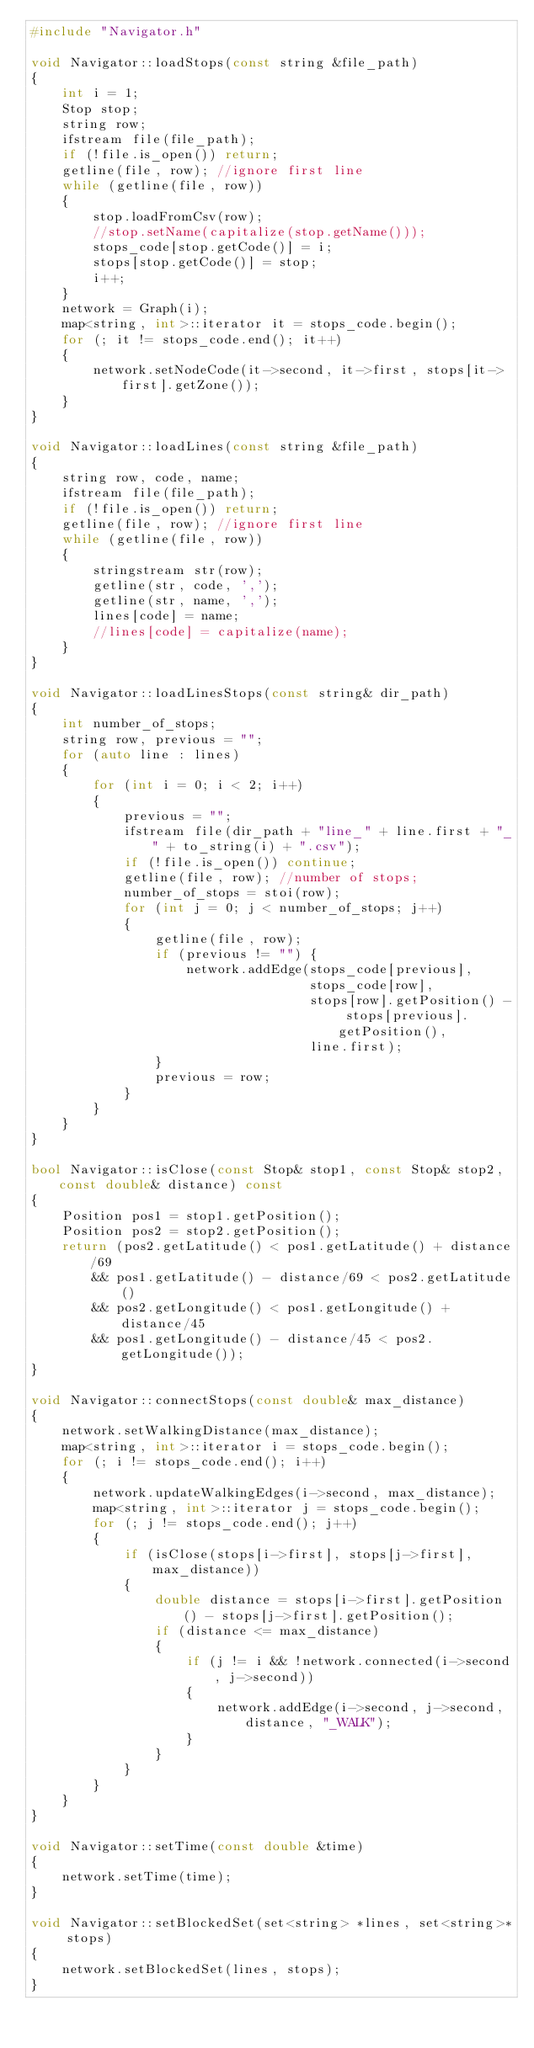<code> <loc_0><loc_0><loc_500><loc_500><_C++_>#include "Navigator.h"

void Navigator::loadStops(const string &file_path)
{
    int i = 1;
    Stop stop;
    string row;
    ifstream file(file_path);
    if (!file.is_open()) return;
    getline(file, row); //ignore first line
    while (getline(file, row))
    {
        stop.loadFromCsv(row);
        //stop.setName(capitalize(stop.getName()));
        stops_code[stop.getCode()] = i;
        stops[stop.getCode()] = stop;
        i++;
    }
    network = Graph(i);
    map<string, int>::iterator it = stops_code.begin();
    for (; it != stops_code.end(); it++)
    {
        network.setNodeCode(it->second, it->first, stops[it->first].getZone());
    }
}

void Navigator::loadLines(const string &file_path)
{
    string row, code, name;
    ifstream file(file_path);
    if (!file.is_open()) return;
    getline(file, row); //ignore first line
    while (getline(file, row))
    {
        stringstream str(row);
        getline(str, code, ',');
        getline(str, name, ',');
        lines[code] = name;
        //lines[code] = capitalize(name);
    }
}

void Navigator::loadLinesStops(const string& dir_path)
{
    int number_of_stops;
    string row, previous = "";
    for (auto line : lines)
    {
        for (int i = 0; i < 2; i++)
        {
            previous = "";
            ifstream file(dir_path + "line_" + line.first + "_" + to_string(i) + ".csv");
            if (!file.is_open()) continue;
            getline(file, row); //number of stops;
            number_of_stops = stoi(row);
            for (int j = 0; j < number_of_stops; j++)
            {
                getline(file, row);
                if (previous != "") {
                    network.addEdge(stops_code[previous],
                                    stops_code[row],
                                    stops[row].getPosition() - stops[previous].getPosition(),
                                    line.first);
                }
                previous = row;
            }
        }
    }
}

bool Navigator::isClose(const Stop& stop1, const Stop& stop2, const double& distance) const
{
    Position pos1 = stop1.getPosition();
    Position pos2 = stop2.getPosition();
    return (pos2.getLatitude() < pos1.getLatitude() + distance/69
        && pos1.getLatitude() - distance/69 < pos2.getLatitude()
        && pos2.getLongitude() < pos1.getLongitude() + distance/45
        && pos1.getLongitude() - distance/45 < pos2.getLongitude());
}

void Navigator::connectStops(const double& max_distance)
{
    network.setWalkingDistance(max_distance);
    map<string, int>::iterator i = stops_code.begin();
    for (; i != stops_code.end(); i++)
    {
        network.updateWalkingEdges(i->second, max_distance);
        map<string, int>::iterator j = stops_code.begin();
        for (; j != stops_code.end(); j++)
        {
            if (isClose(stops[i->first], stops[j->first], max_distance))
            {
                double distance = stops[i->first].getPosition() - stops[j->first].getPosition();
                if (distance <= max_distance)
                {
                    if (j != i && !network.connected(i->second, j->second))
                    {
                        network.addEdge(i->second, j->second, distance, "_WALK");
                    }
                }
            }
        }
    }
}

void Navigator::setTime(const double &time)
{
    network.setTime(time);
}

void Navigator::setBlockedSet(set<string> *lines, set<string>* stops)
{
    network.setBlockedSet(lines, stops);
}
</code> 